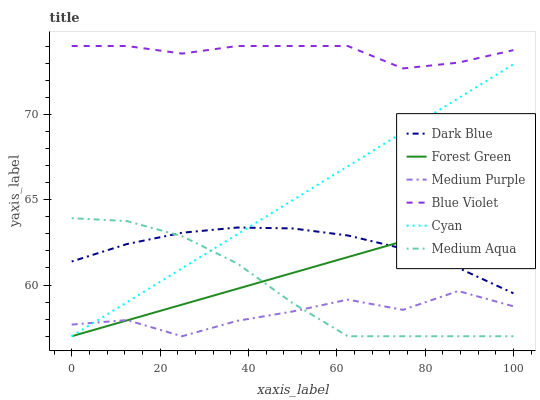Does Dark Blue have the minimum area under the curve?
Answer yes or no. No. Does Dark Blue have the maximum area under the curve?
Answer yes or no. No. Is Dark Blue the smoothest?
Answer yes or no. No. Is Dark Blue the roughest?
Answer yes or no. No. Does Dark Blue have the lowest value?
Answer yes or no. No. Does Dark Blue have the highest value?
Answer yes or no. No. Is Dark Blue less than Blue Violet?
Answer yes or no. Yes. Is Blue Violet greater than Dark Blue?
Answer yes or no. Yes. Does Dark Blue intersect Blue Violet?
Answer yes or no. No. 